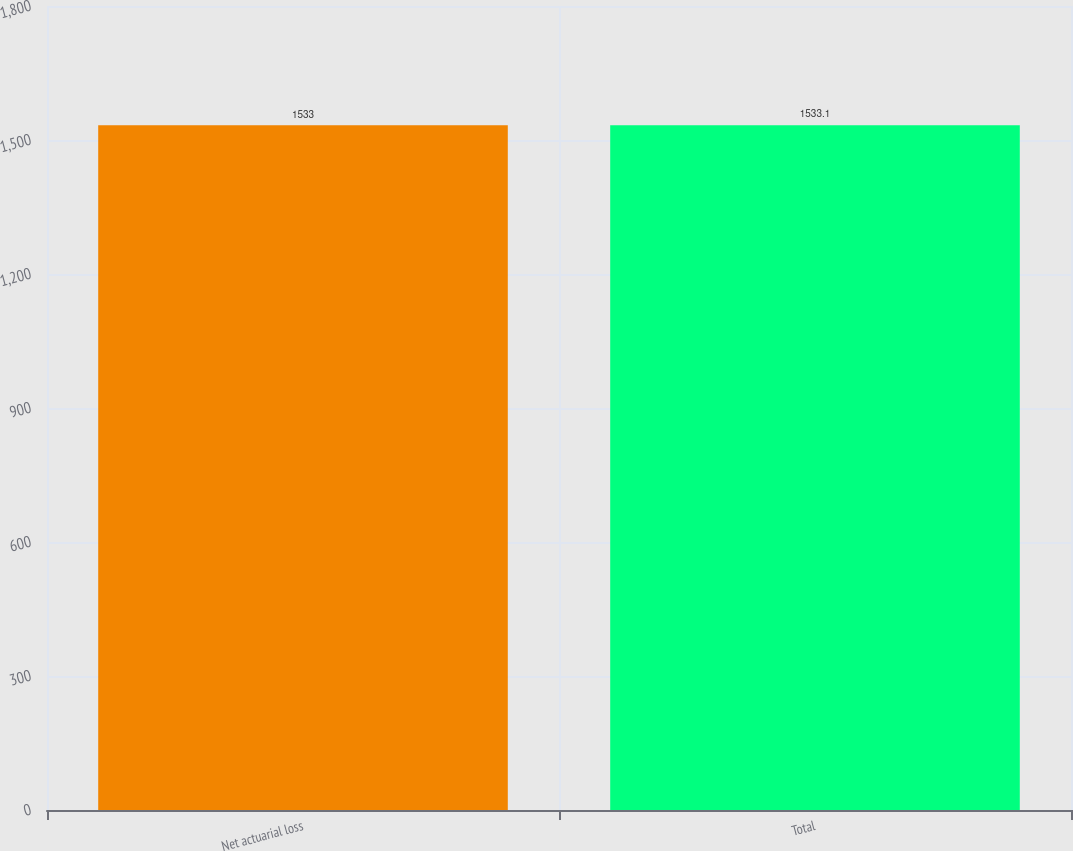<chart> <loc_0><loc_0><loc_500><loc_500><bar_chart><fcel>Net actuarial loss<fcel>Total<nl><fcel>1533<fcel>1533.1<nl></chart> 